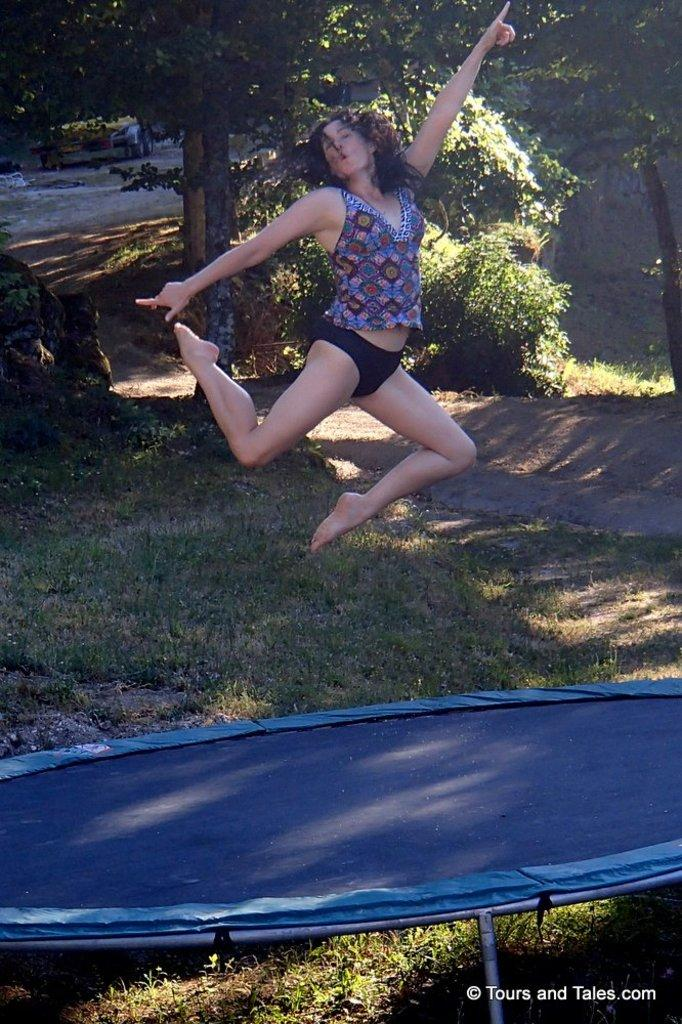Who is the main subject in the image? There is a woman in the image. What is the woman doing in the image? The woman is jumping on a trampoline. What color is the trampoline? The trampoline is blue in color. What is the trampoline placed on? The trampoline is on green grass. What can be seen in the background of the image? There are trees in the background of the image. Can you hear the woman laughing while jumping on the trampoline in the image? The image is silent, so we cannot hear the woman laughing or any other sounds. Is there a donkey present in the image? No, there is no donkey present in the image. 